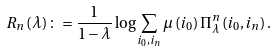<formula> <loc_0><loc_0><loc_500><loc_500>R _ { n } \left ( \lambda \right ) \colon = \frac { 1 } { 1 - \lambda } \log \sum _ { i _ { 0 } , i _ { n } } \mu \left ( i _ { 0 } \right ) \Pi _ { \lambda } ^ { n } \left ( i _ { 0 } , i _ { n } \right ) .</formula> 